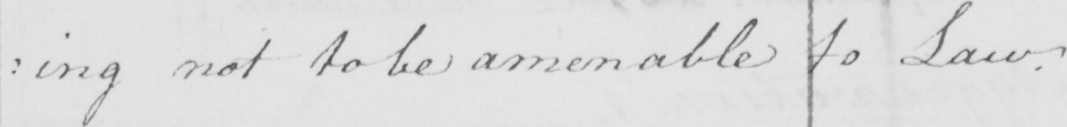What text is written in this handwritten line? : ing not to be amenable to Law . 